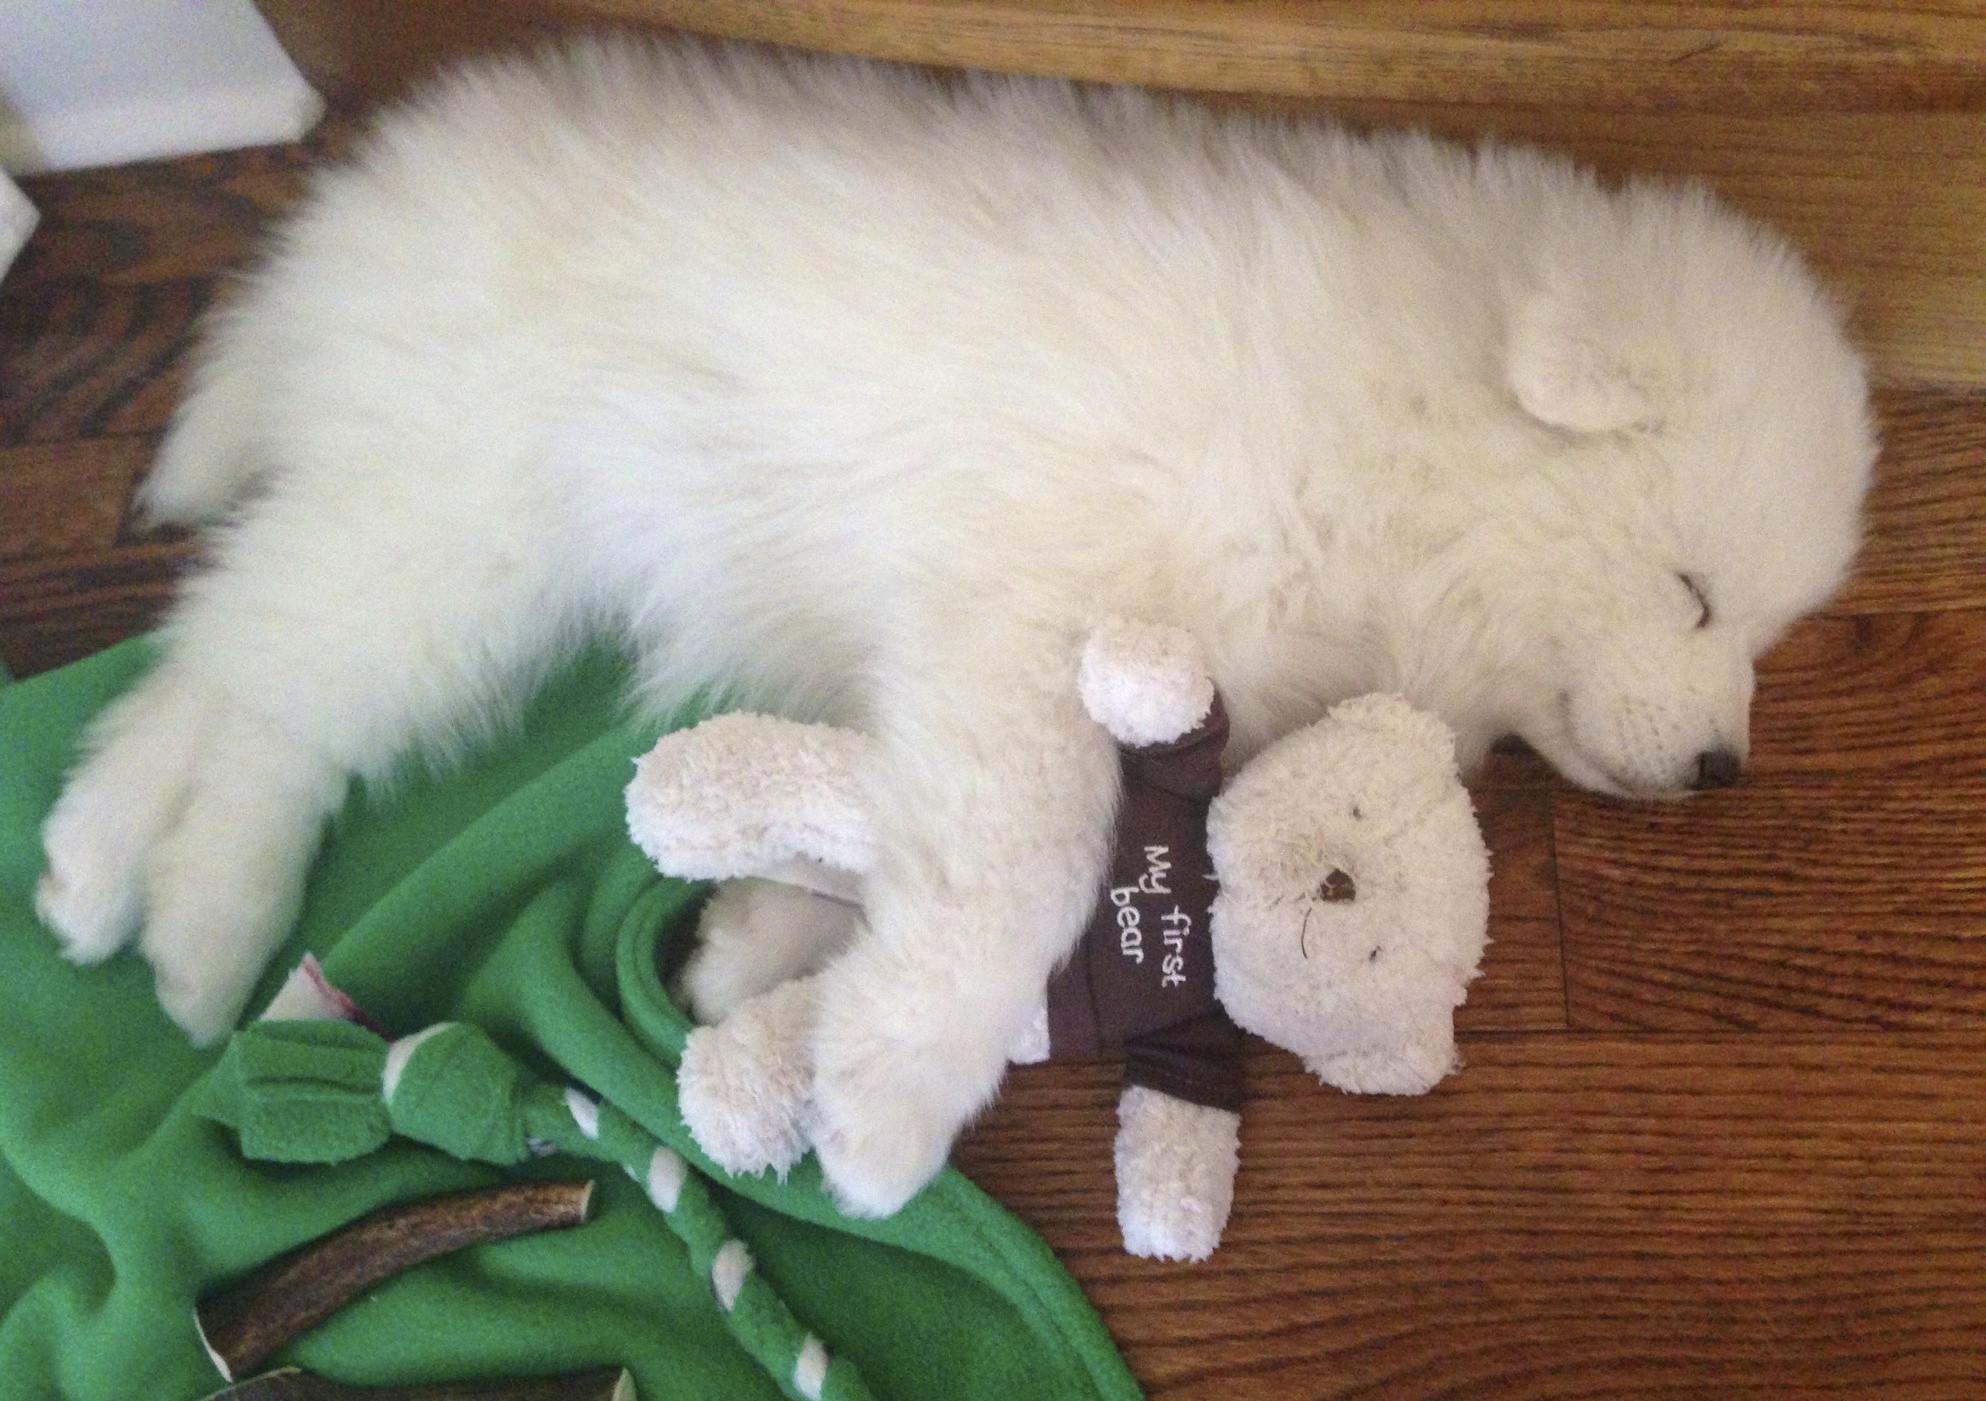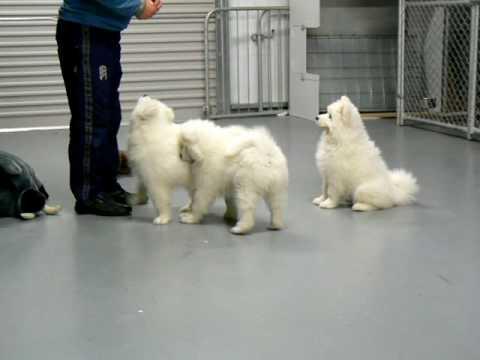The first image is the image on the left, the second image is the image on the right. For the images displayed, is the sentence "The right image contains at least three white dogs." factually correct? Answer yes or no. Yes. The first image is the image on the left, the second image is the image on the right. Evaluate the accuracy of this statement regarding the images: "At least one white dog is standing next to a person's legs.". Is it true? Answer yes or no. Yes. The first image is the image on the left, the second image is the image on the right. Analyze the images presented: Is the assertion "There are five white and fluffy dogs including a single dog sitting." valid? Answer yes or no. No. The first image is the image on the left, the second image is the image on the right. Considering the images on both sides, is "An image features one white dog sleeping near one stuffed animal toy." valid? Answer yes or no. Yes. 